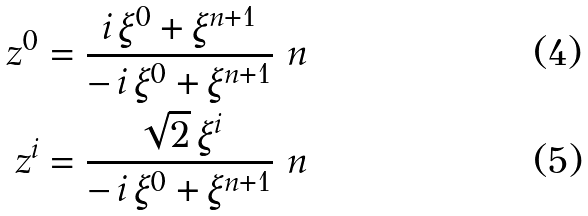Convert formula to latex. <formula><loc_0><loc_0><loc_500><loc_500>z ^ { 0 } & = \frac { i \, \xi ^ { 0 } + \xi ^ { n + 1 } } { - \, i \, \xi ^ { 0 } + \xi ^ { n + 1 } } \ n \\ z ^ { i } & = \frac { \sqrt { 2 } \, \xi ^ { i } } { - \, i \, \xi ^ { 0 } + \xi ^ { n + 1 } } \ n</formula> 